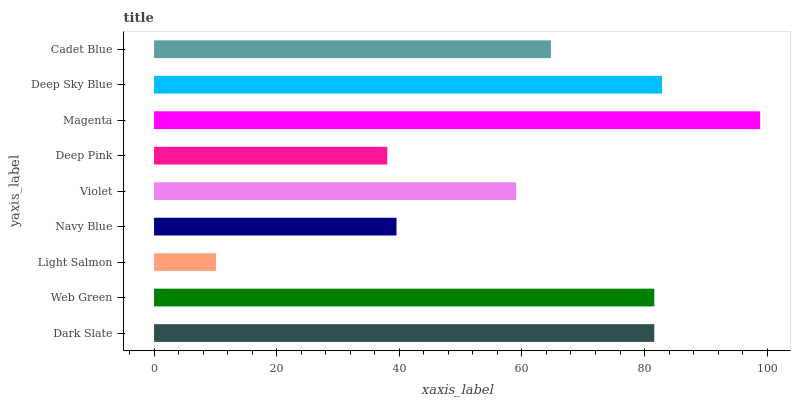Is Light Salmon the minimum?
Answer yes or no. Yes. Is Magenta the maximum?
Answer yes or no. Yes. Is Web Green the minimum?
Answer yes or no. No. Is Web Green the maximum?
Answer yes or no. No. Is Dark Slate greater than Web Green?
Answer yes or no. Yes. Is Web Green less than Dark Slate?
Answer yes or no. Yes. Is Web Green greater than Dark Slate?
Answer yes or no. No. Is Dark Slate less than Web Green?
Answer yes or no. No. Is Cadet Blue the high median?
Answer yes or no. Yes. Is Cadet Blue the low median?
Answer yes or no. Yes. Is Violet the high median?
Answer yes or no. No. Is Dark Slate the low median?
Answer yes or no. No. 